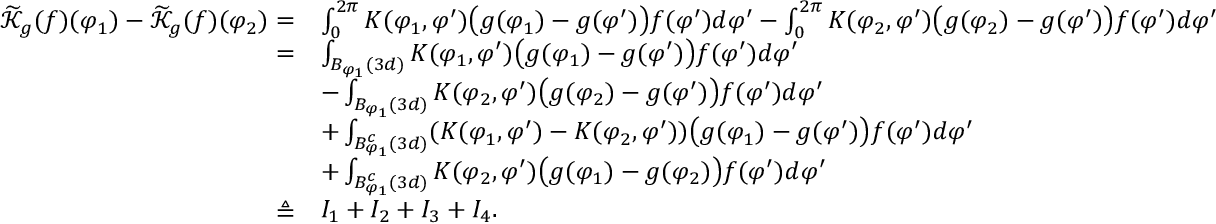<formula> <loc_0><loc_0><loc_500><loc_500>\begin{array} { r l } { \widetilde { \mathcal { K } } _ { g } ( f ) ( \varphi _ { 1 } ) - \widetilde { \mathcal { K } } _ { g } ( f ) ( \varphi _ { 2 } ) = } & { \int _ { 0 } ^ { 2 \pi } K ( \varphi _ { 1 } , \varphi ^ { \prime } ) \left ( g ( \varphi _ { 1 } ) - g ( \varphi ^ { \prime } ) \right ) f ( \varphi ^ { \prime } ) d \varphi ^ { \prime } - \int _ { 0 } ^ { 2 \pi } K ( \varphi _ { 2 } , \varphi ^ { \prime } ) \left ( g ( \varphi _ { 2 } ) - g ( \varphi ^ { \prime } ) \right ) f ( \varphi ^ { \prime } ) d \varphi ^ { \prime } } \\ { = } & { \int _ { B _ { \varphi _ { 1 } } ( 3 d ) } K ( \varphi _ { 1 } , \varphi ^ { \prime } ) \left ( g ( \varphi _ { 1 } ) - g ( \varphi ^ { \prime } ) \right ) f ( \varphi ^ { \prime } ) d \varphi ^ { \prime } } \\ & { - \int _ { B _ { \varphi _ { 1 } } ( 3 d ) } K ( \varphi _ { 2 } , \varphi ^ { \prime } ) \left ( g ( \varphi _ { 2 } ) - g ( \varphi ^ { \prime } ) \right ) f ( \varphi ^ { \prime } ) d \varphi ^ { \prime } } \\ & { + \int _ { B _ { \varphi _ { 1 } } ^ { c } ( 3 d ) } ( K ( \varphi _ { 1 } , \varphi ^ { \prime } ) - K ( \varphi _ { 2 } , \varphi ^ { \prime } ) ) \left ( g ( \varphi _ { 1 } ) - g ( \varphi ^ { \prime } ) \right ) f ( \varphi ^ { \prime } ) d \varphi ^ { \prime } } \\ & { + \int _ { B _ { \varphi _ { 1 } } ^ { c } ( 3 d ) } K ( \varphi _ { 2 } , \varphi ^ { \prime } ) \left ( g ( \varphi _ { 1 } ) - g ( \varphi _ { 2 } ) \right ) f ( \varphi ^ { \prime } ) d \varphi ^ { \prime } } \\ { \triangle q } & { I _ { 1 } + I _ { 2 } + I _ { 3 } + I _ { 4 } . } \end{array}</formula> 